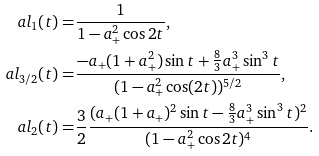Convert formula to latex. <formula><loc_0><loc_0><loc_500><loc_500>\ a l _ { 1 } ( t ) = & \frac { 1 } { 1 - a ^ { 2 } _ { + } \cos 2 t } , \\ \ a l _ { 3 / 2 } ( t ) = & \frac { - a _ { + } ( 1 + a ^ { 2 } _ { + } ) \sin t + \frac { 8 } { 3 } a ^ { 3 } _ { + } \sin ^ { 3 } t } { ( 1 - a ^ { 2 } _ { + } \cos ( 2 t ) ) ^ { 5 / 2 } } , \\ \ a l _ { 2 } ( t ) = & \frac { 3 } { 2 } \frac { ( a _ { + } ( 1 + a _ { + } ) ^ { 2 } \sin t - \frac { 8 } { 3 } a ^ { 3 } _ { + } \sin ^ { 3 } t ) ^ { 2 } } { ( 1 - a ^ { 2 } _ { + } \cos 2 t ) ^ { 4 } } .</formula> 